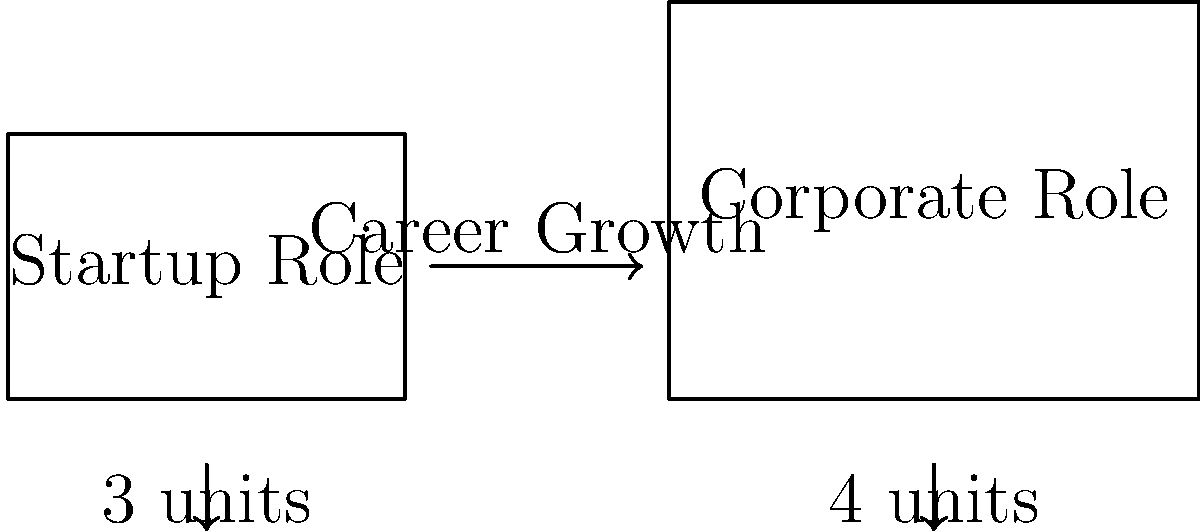In the diagram, two rectangles represent Nir Bardea's roles in his career journey. The left rectangle symbolizes his startup role, while the right rectangle represents his corporate role. If the width of the startup role rectangle is 3 units and the width of the corporate role rectangle is 4 units, are these two shapes congruent? To determine if the two rectangles are congruent, we need to compare their shapes and sizes. Two shapes are congruent if they have the same shape and size, even if they are oriented differently.

Let's analyze the rectangles step-by-step:

1. Shape: Both figures are rectangles, so they have the same shape.

2. Dimensions:
   - Startup role rectangle:
     Width = 3 units
     Height = 2 units (given in the diagram)
   - Corporate role rectangle:
     Width = 4 units
     Height = 3 units (given in the diagram)

3. Comparing dimensions:
   - The widths are different (3 units vs. 4 units)
   - The heights are different (2 units vs. 3 units)

4. Area comparison:
   - Startup role area = 3 * 2 = 6 square units
   - Corporate role area = 4 * 3 = 12 square units

5. Conclusion:
   Since the dimensions and areas of the rectangles are different, they cannot be congruent. The corporate role rectangle is larger than the startup role rectangle, which could symbolize Nir Bardea's career growth and progression to larger responsibilities.
Answer: No, the shapes are not congruent. 